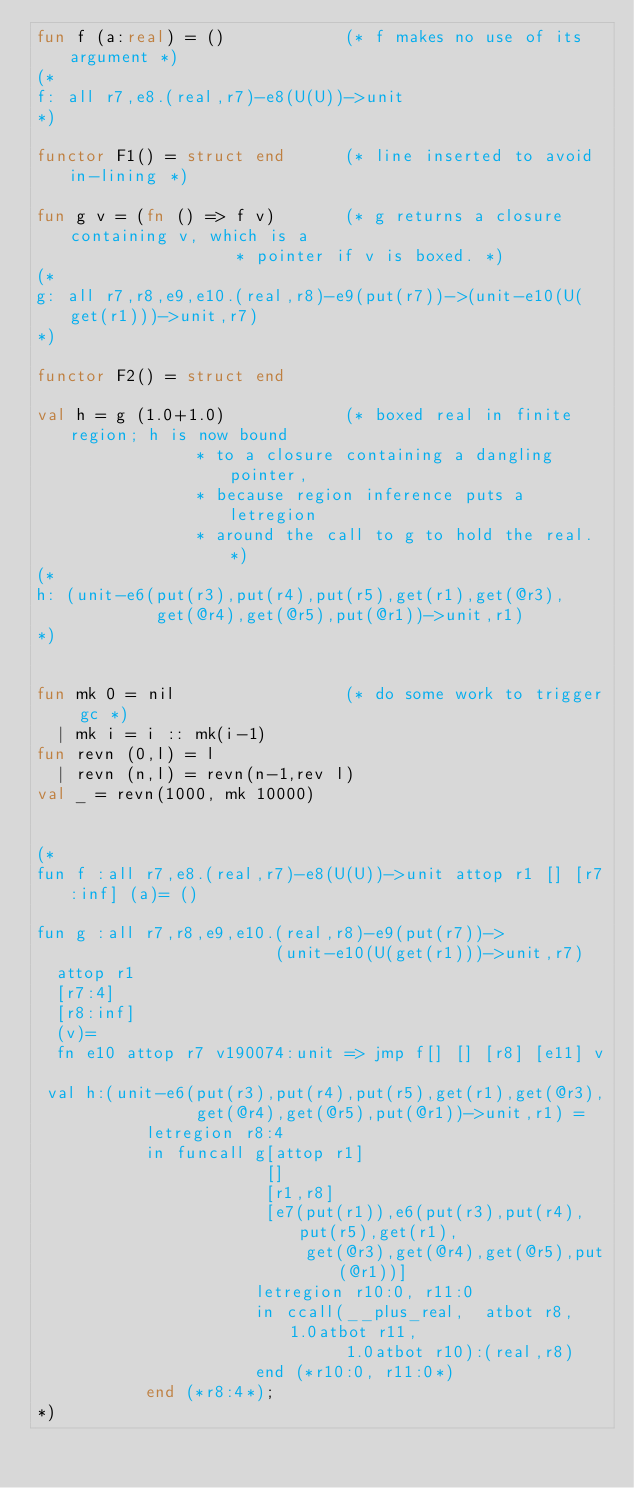<code> <loc_0><loc_0><loc_500><loc_500><_SML_>fun f (a:real) = ()            (* f makes no use of its argument *)
(*
f: all r7,e8.(real,r7)-e8(U(U))->unit
*)

functor F1() = struct end      (* line inserted to avoid in-lining *)

fun g v = (fn () => f v)       (* g returns a closure containing v, which is a 
			        * pointer if v is boxed. *)
(*
g: all r7,r8,e9,e10.(real,r8)-e9(put(r7))->(unit-e10(U(get(r1)))->unit,r7) 
*)

functor F2() = struct end

val h = g (1.0+1.0)            (* boxed real in finite region; h is now bound 
				* to a closure containing a dangling pointer, 
				* because region inference puts a letregion 
				* around the call to g to hold the real. *)
(*
h: (unit-e6(put(r3),put(r4),put(r5),get(r1),get(@r3),
            get(@r4),get(@r5),put(@r1))->unit,r1)
*)


fun mk 0 = nil                 (* do some work to trigger gc *)
  | mk i = i :: mk(i-1)
fun revn (0,l) = l
  | revn (n,l) = revn(n-1,rev l) 
val _ = revn(1000, mk 10000)


(*
fun f :all r7,e8.(real,r7)-e8(U(U))->unit attop r1 [] [r7:inf] (a)= ()

fun g :all r7,r8,e9,e10.(real,r8)-e9(put(r7))->
                        (unit-e10(U(get(r1)))->unit,r7) 
  attop r1 
  [r7:4] 
  [r8:inf] 
  (v)= 
  fn e10 attop r7 v190074:unit => jmp f[] [] [r8] [e11] v

 val h:(unit-e6(put(r3),put(r4),put(r5),get(r1),get(@r3),
                get(@r4),get(@r5),put(@r1))->unit,r1) = 
           letregion r8:4 
           in funcall g[attop r1] 
                       [] 
                       [r1,r8] 
                       [e7(put(r1)),e6(put(r3),put(r4),put(r5),get(r1),
                           get(@r3),get(@r4),get(@r5),put(@r1))] 
                      letregion r10:0, r11:0 
                      in ccall(__plus_real,  atbot r8, 1.0atbot r11, 
                               1.0atbot r10):(real,r8) 
                      end (*r10:0, r11:0*) 
           end (*r8:4*); 
*)</code> 